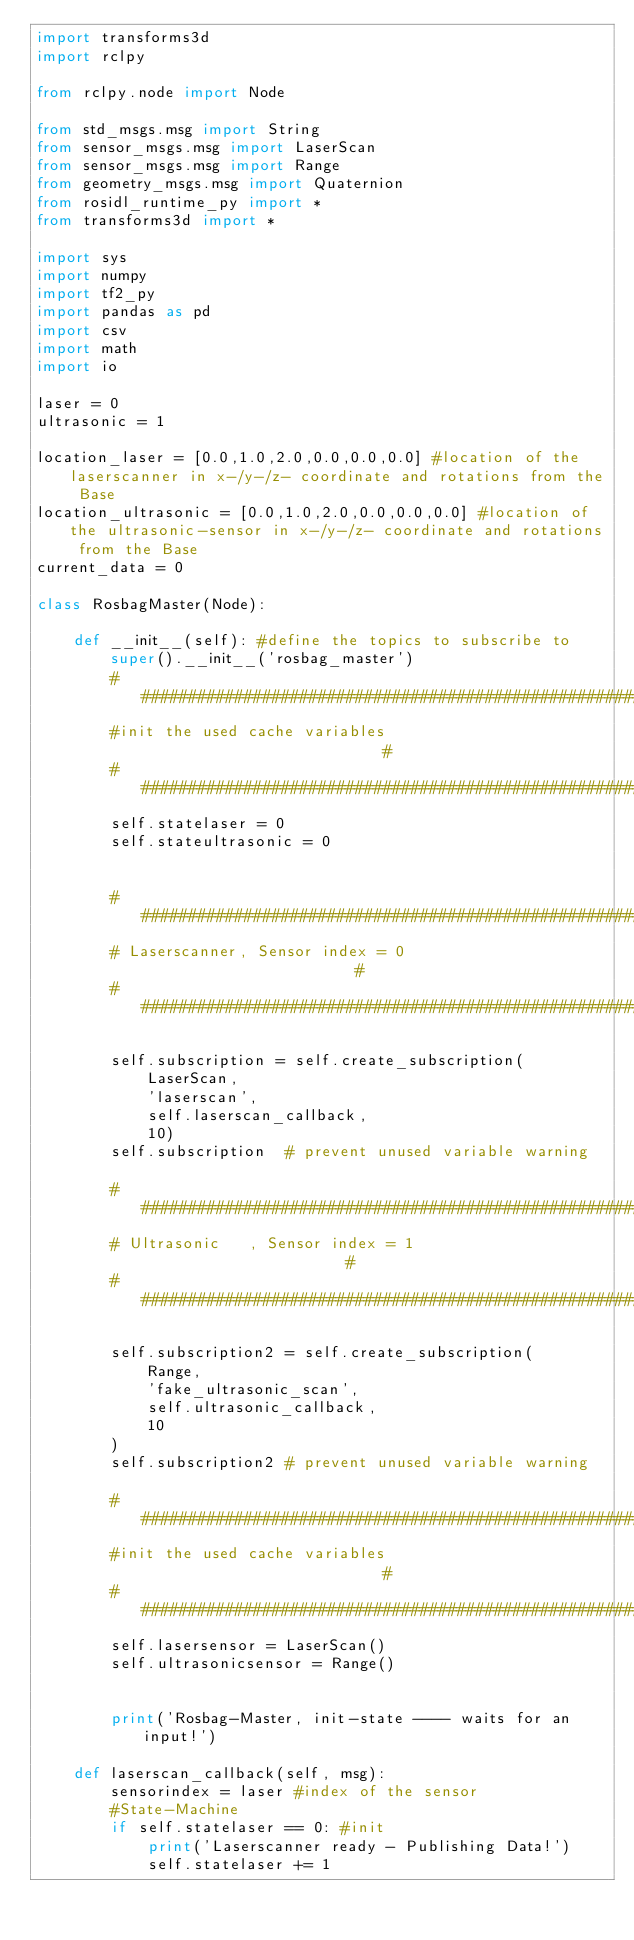Convert code to text. <code><loc_0><loc_0><loc_500><loc_500><_Python_>import transforms3d
import rclpy

from rclpy.node import Node

from std_msgs.msg import String
from sensor_msgs.msg import LaserScan
from sensor_msgs.msg import Range
from geometry_msgs.msg import Quaternion
from rosidl_runtime_py import *
from transforms3d import *

import sys
import numpy
import tf2_py
import pandas as pd  
import csv
import math
import io

laser = 0
ultrasonic = 1

location_laser = [0.0,1.0,2.0,0.0,0.0,0.0] #location of the laserscanner in x-/y-/z- coordinate and rotations from the Base
location_ultrasonic = [0.0,1.0,2.0,0.0,0.0,0.0] #location of the ultrasonic-sensor in x-/y-/z- coordinate and rotations from the Base
current_data = 0

class RosbagMaster(Node):

    def __init__(self): #define the topics to subscribe to 
        super().__init__('rosbag_master')
        ##########################################################
        #init the used cache variables                           #
        ##########################################################
        self.statelaser = 0
        self.stateultrasonic = 0


        #########################################################
        # Laserscanner, Sensor index = 0                        #
        #########################################################

        self.subscription = self.create_subscription(
            LaserScan,
            'laserscan',
            self.laserscan_callback,
            10)
        self.subscription  # prevent unused variable warning
        
        #########################################################
        # Ultrasonic   , Sensor index = 1                       #
        #########################################################

        self.subscription2 = self.create_subscription(
            Range,
            'fake_ultrasonic_scan',
            self.ultrasonic_callback,
            10
        )
        self.subscription2 # prevent unused variable warning
        
        ##########################################################
        #init the used cache variables                           #
        ##########################################################
        self.lasersensor = LaserScan()
        self.ultrasonicsensor = Range()

        
        print('Rosbag-Master, init-state ---- waits for an input!')

    def laserscan_callback(self, msg):
        sensorindex = laser #index of the sensor
        #State-Machine
        if self.statelaser == 0: #init
            print('Laserscanner ready - Publishing Data!')
            self.statelaser += 1
</code> 